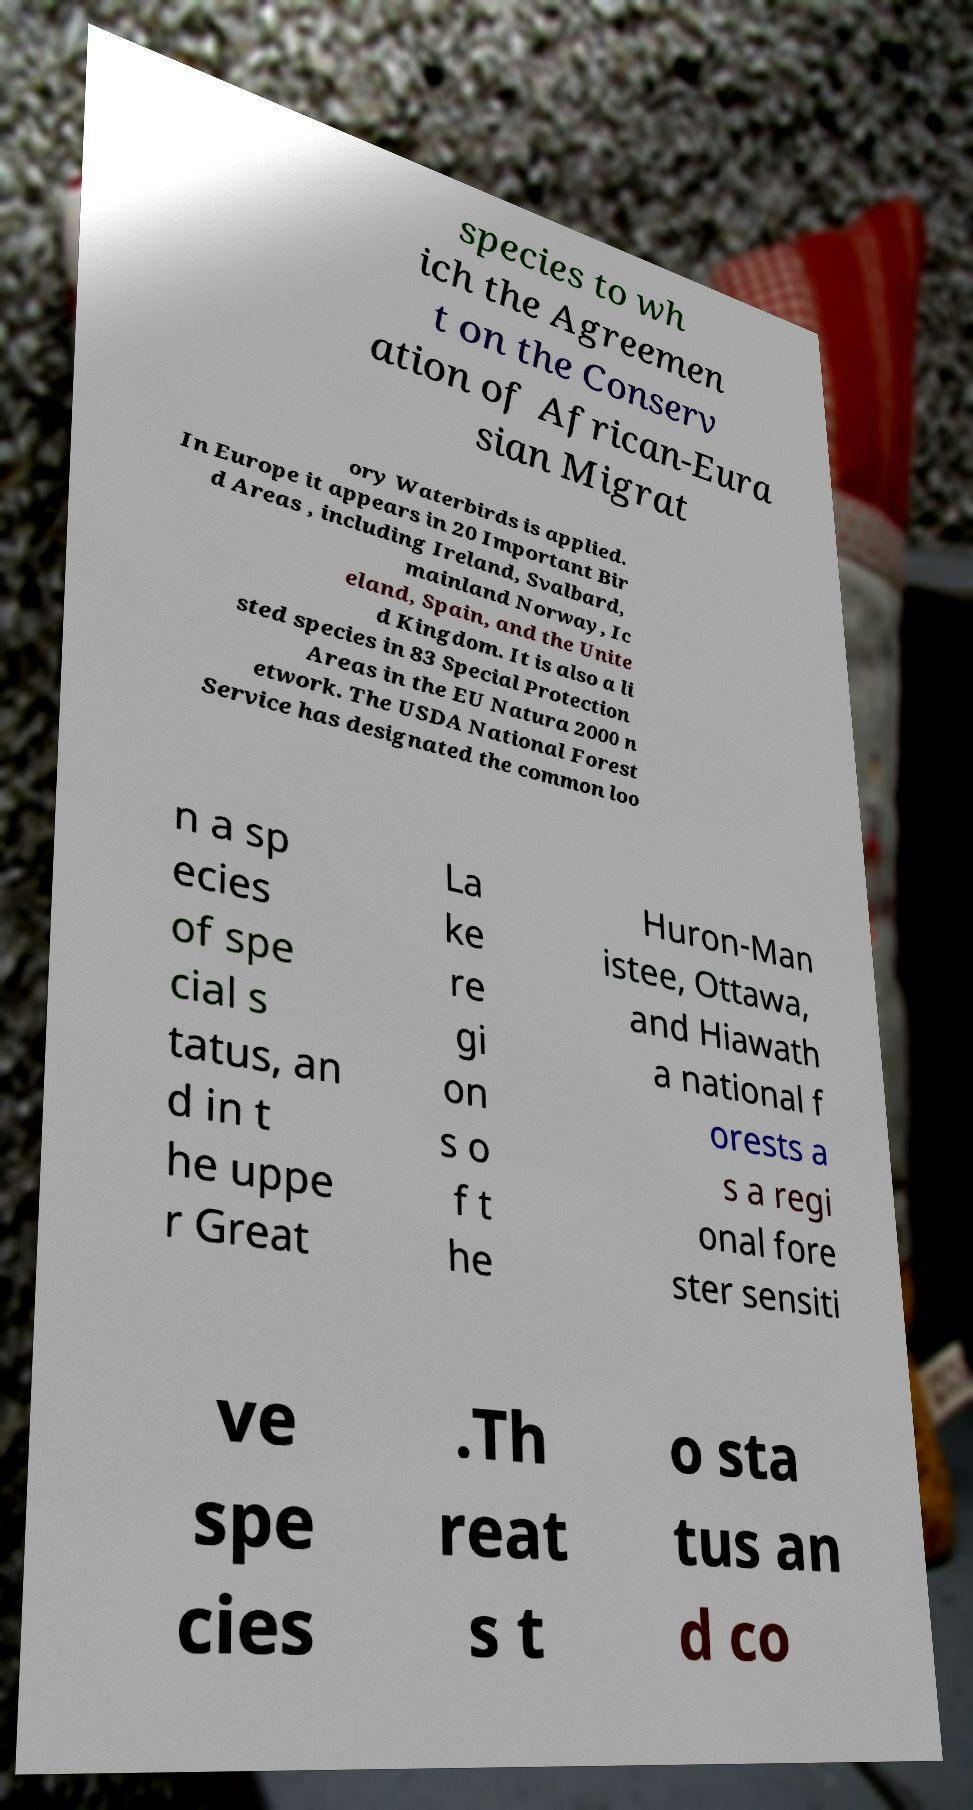Could you assist in decoding the text presented in this image and type it out clearly? species to wh ich the Agreemen t on the Conserv ation of African-Eura sian Migrat ory Waterbirds is applied. In Europe it appears in 20 Important Bir d Areas , including Ireland, Svalbard, mainland Norway, Ic eland, Spain, and the Unite d Kingdom. It is also a li sted species in 83 Special Protection Areas in the EU Natura 2000 n etwork. The USDA National Forest Service has designated the common loo n a sp ecies of spe cial s tatus, an d in t he uppe r Great La ke re gi on s o f t he Huron-Man istee, Ottawa, and Hiawath a national f orests a s a regi onal fore ster sensiti ve spe cies .Th reat s t o sta tus an d co 